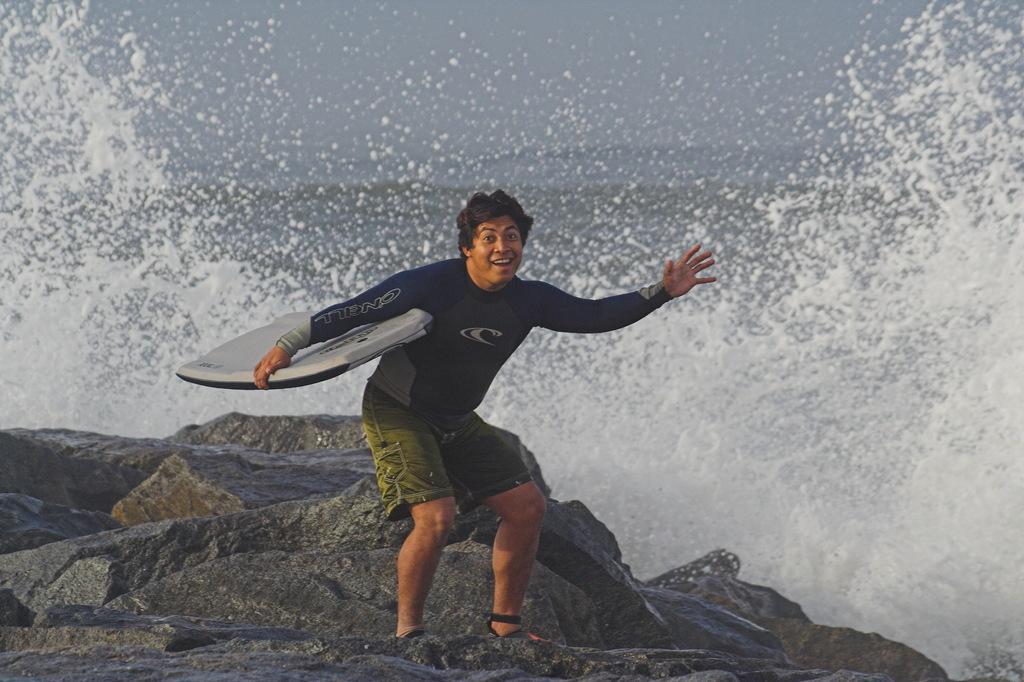How would you summarize this image in a sentence or two? In this picture there is a man standing and smiling and he is holding surfing board. At the back there is a water, at the top there is a sky, at the bottom there is a rock. 